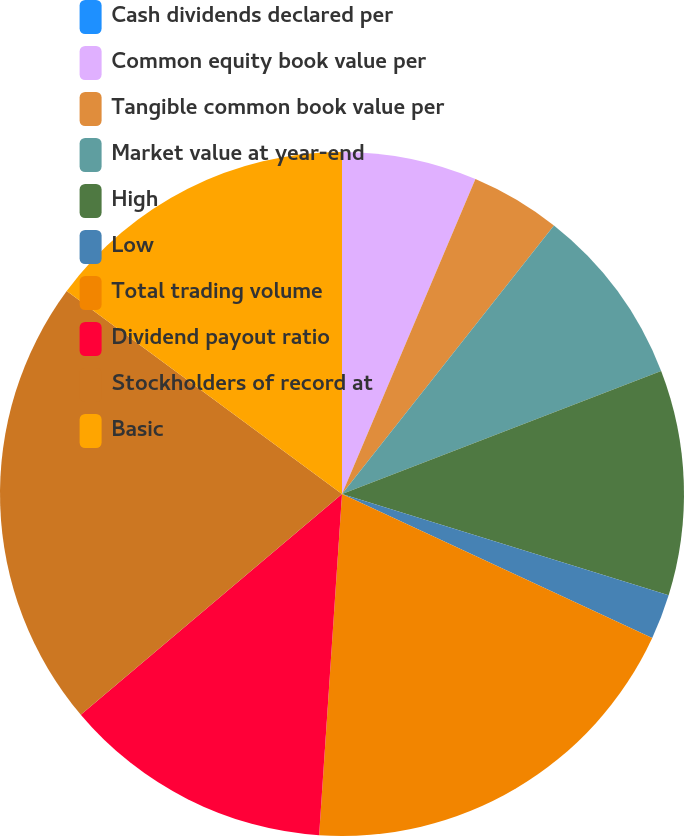<chart> <loc_0><loc_0><loc_500><loc_500><pie_chart><fcel>Cash dividends declared per<fcel>Common equity book value per<fcel>Tangible common book value per<fcel>Market value at year-end<fcel>High<fcel>Low<fcel>Total trading volume<fcel>Dividend payout ratio<fcel>Stockholders of record at<fcel>Basic<nl><fcel>0.0%<fcel>6.38%<fcel>4.26%<fcel>8.51%<fcel>10.64%<fcel>2.13%<fcel>19.15%<fcel>12.77%<fcel>21.28%<fcel>14.89%<nl></chart> 